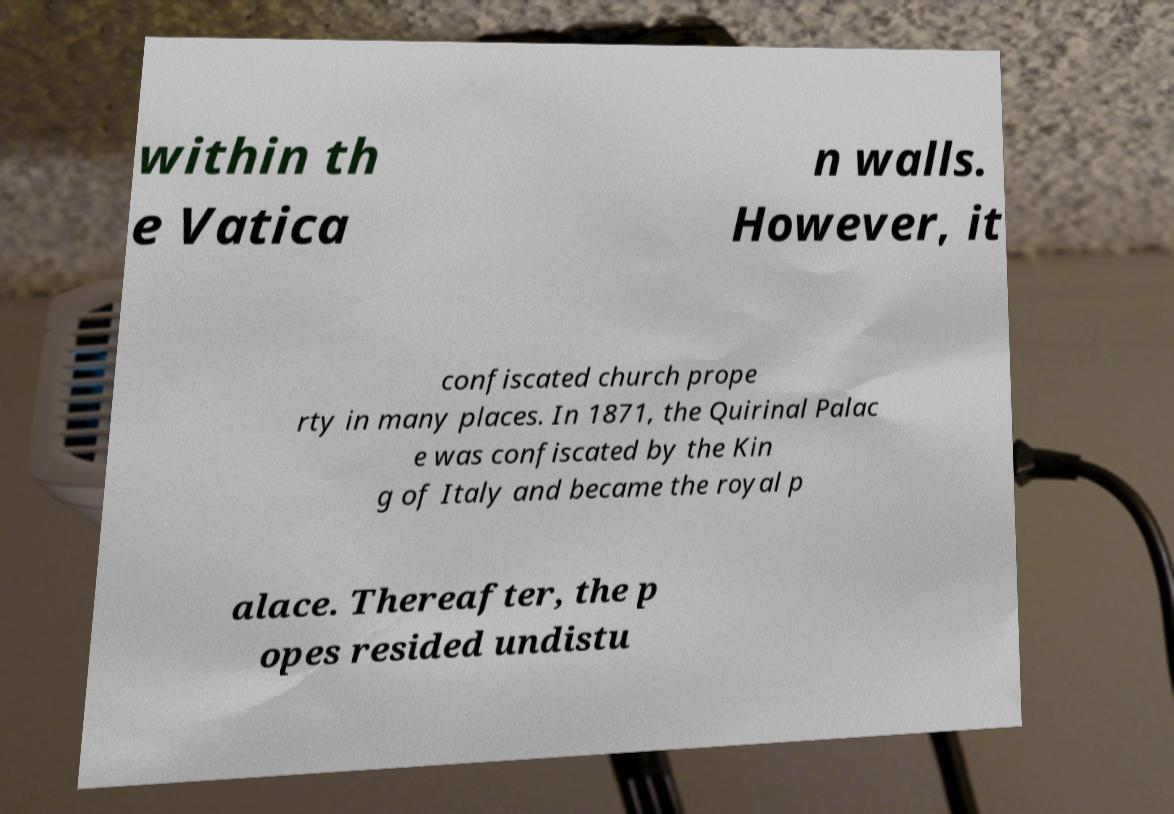Please read and relay the text visible in this image. What does it say? within th e Vatica n walls. However, it confiscated church prope rty in many places. In 1871, the Quirinal Palac e was confiscated by the Kin g of Italy and became the royal p alace. Thereafter, the p opes resided undistu 